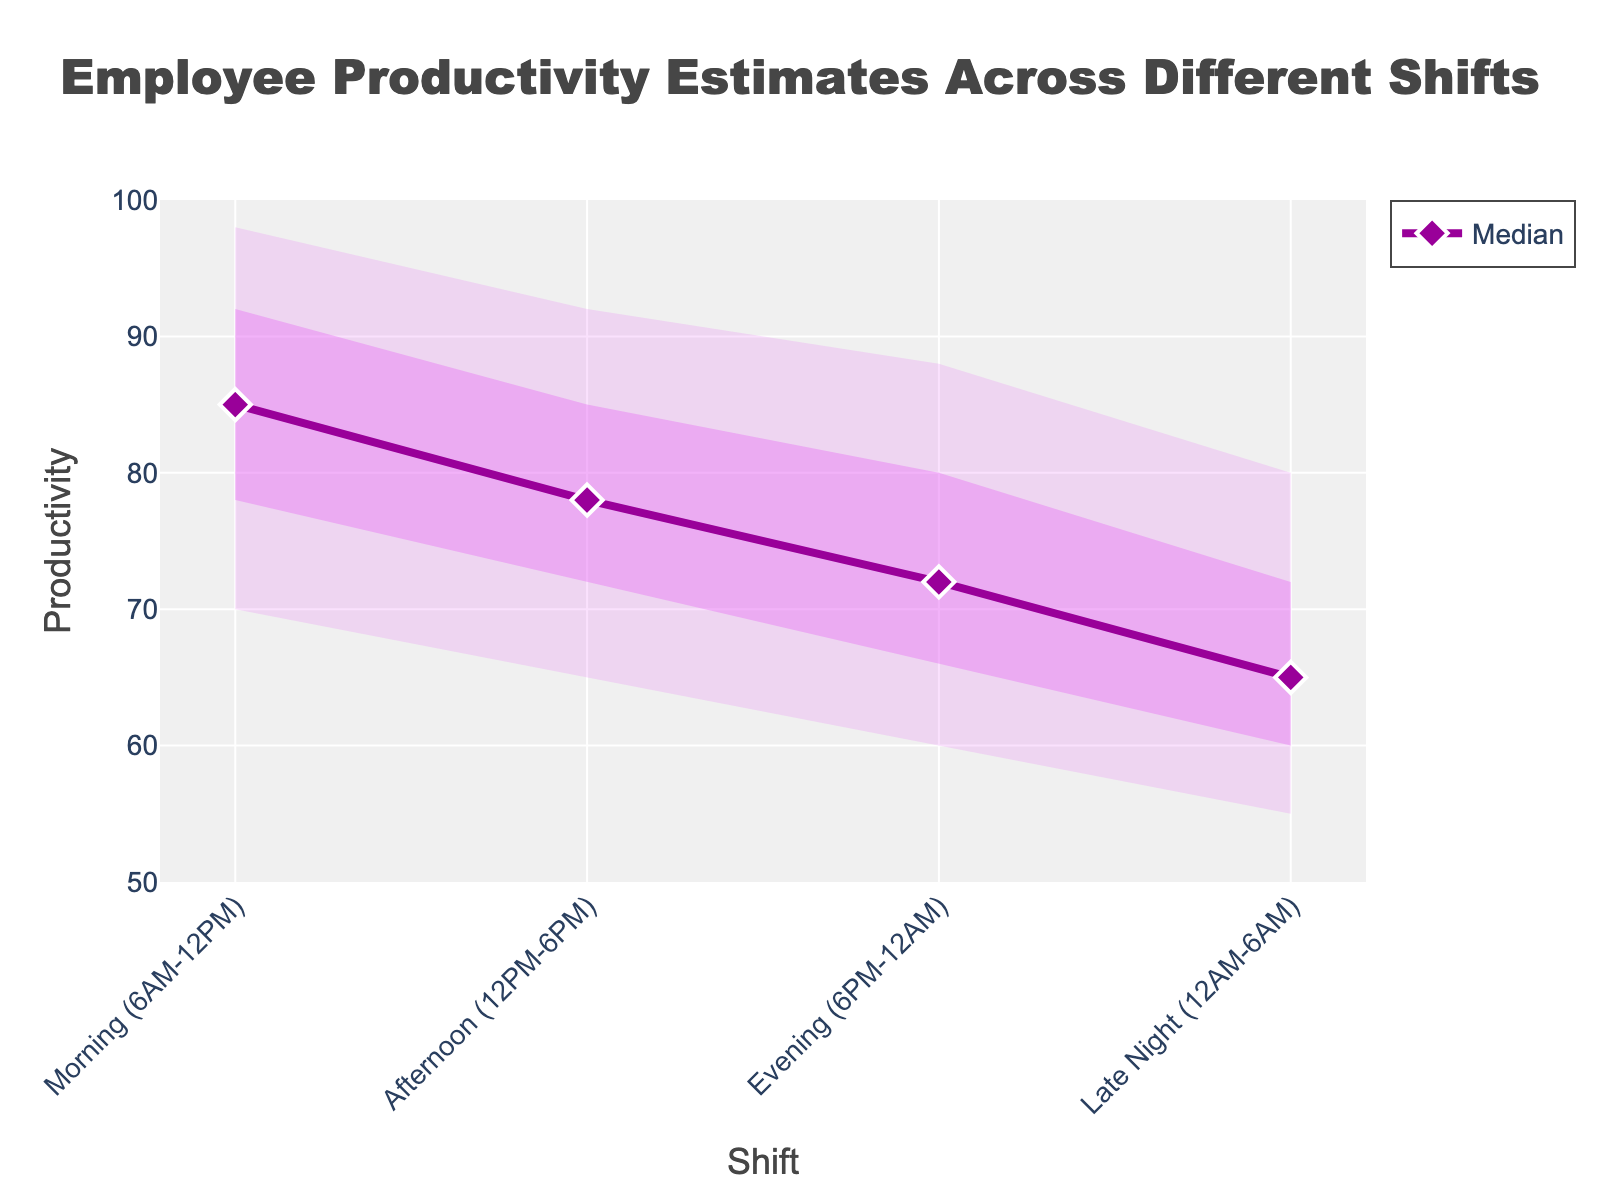What is the title of the chart? The title of the chart is displayed at the top and center of the plot. It reads "Employee Productivity Estimates Across Different Shifts".
Answer: Employee Productivity Estimates Across Different Shifts What shift has the highest median productivity? By looking at the median line (the darker, central line) across different shifts, the Morning shift has the highest median productivity at 85.
Answer: Morning Which shift has the widest 90% confidence interval in productivity? The 90% confidence interval is represented by the lightest shaded area. The Morning shift has the widest 90% confidence interval, ranging from 70 to 98.
Answer: Morning What is the difference in median productivity between the Morning and Late Night shifts? Looking at the median values, the Morning shift has a median productivity of 85 while the Late Night shift has a median productivity of 65. The difference is 85 - 65 = 20.
Answer: 20 Which shift has the lowest 10th percentile in productivity? The 10th percentile productivity is indicated by the lower boundary of the lightest shaded area. The Late Night shift has the lowest 10th percentile value at 55.
Answer: Late Night For the Afternoon shift, what is the range between the 25th and 75th percentiles? The 25th percentile value for the Afternoon shift is 72 and the 75th percentile value is 85. The range is 85 - 72 = 13.
Answer: 13 How does the confidence interval for the Evening shift compare between the 50% and 90% levels? The lighter shaded area represents the 90% confidence interval (60 to 88) and the darker shaded area represents the 50% confidence interval (66 to 80). The 90% confidence interval is wider than the 50% confidence interval.
Answer: 90% is wider than 50% Which shift shows the greatest decrease in median productivity compared to the previous shift? By comparing the median productivity values across shifts in sequence, the greatest decrease occurs between the Morning (85) and Afternoon (78) shifts, a drop of 7.
Answer: Morning to Afternoon What is the median productivity for the Evening shift? From the plot, the median productivity for the Evening shift is represented by the central line, which is at 72.
Answer: 72 